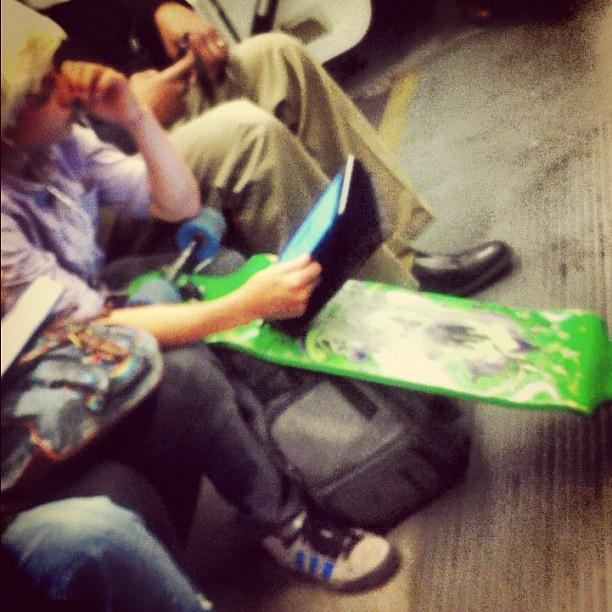What device is the boy holding? tablet 